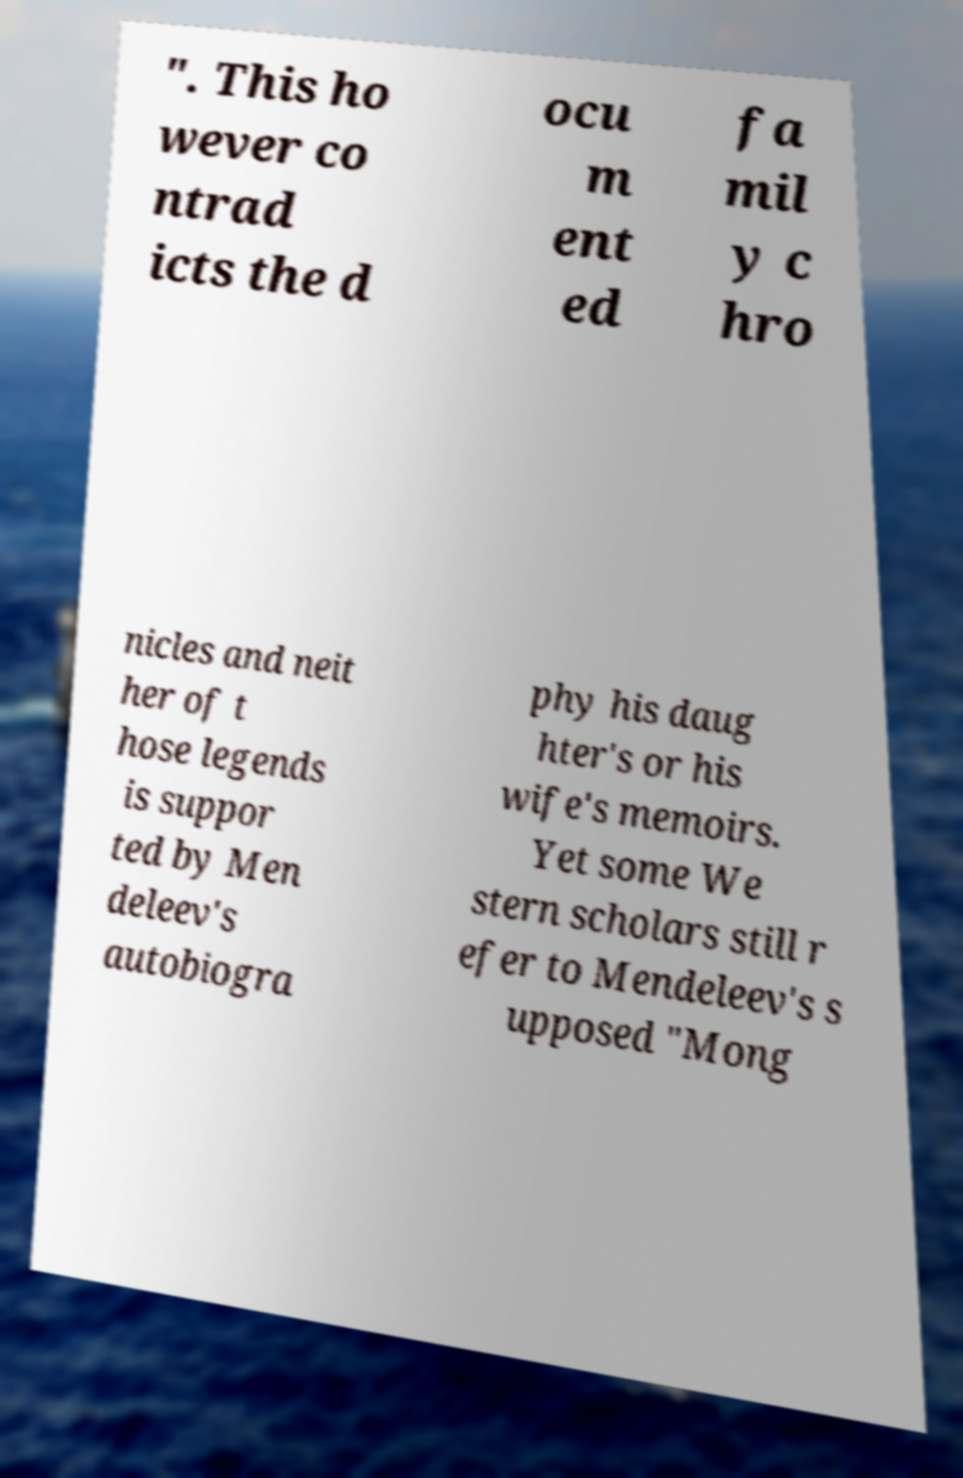Please identify and transcribe the text found in this image. ". This ho wever co ntrad icts the d ocu m ent ed fa mil y c hro nicles and neit her of t hose legends is suppor ted by Men deleev's autobiogra phy his daug hter's or his wife's memoirs. Yet some We stern scholars still r efer to Mendeleev's s upposed "Mong 